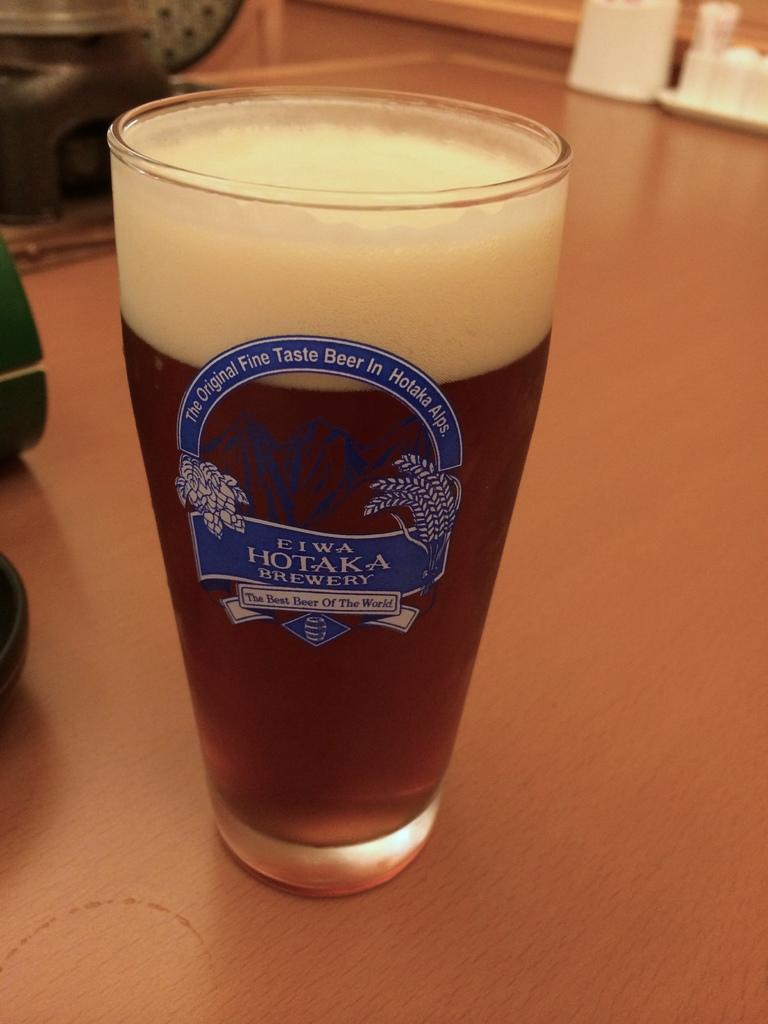Describe this image in one or two sentences. Here in this picture we can see a glass of beer present on the table over there. 